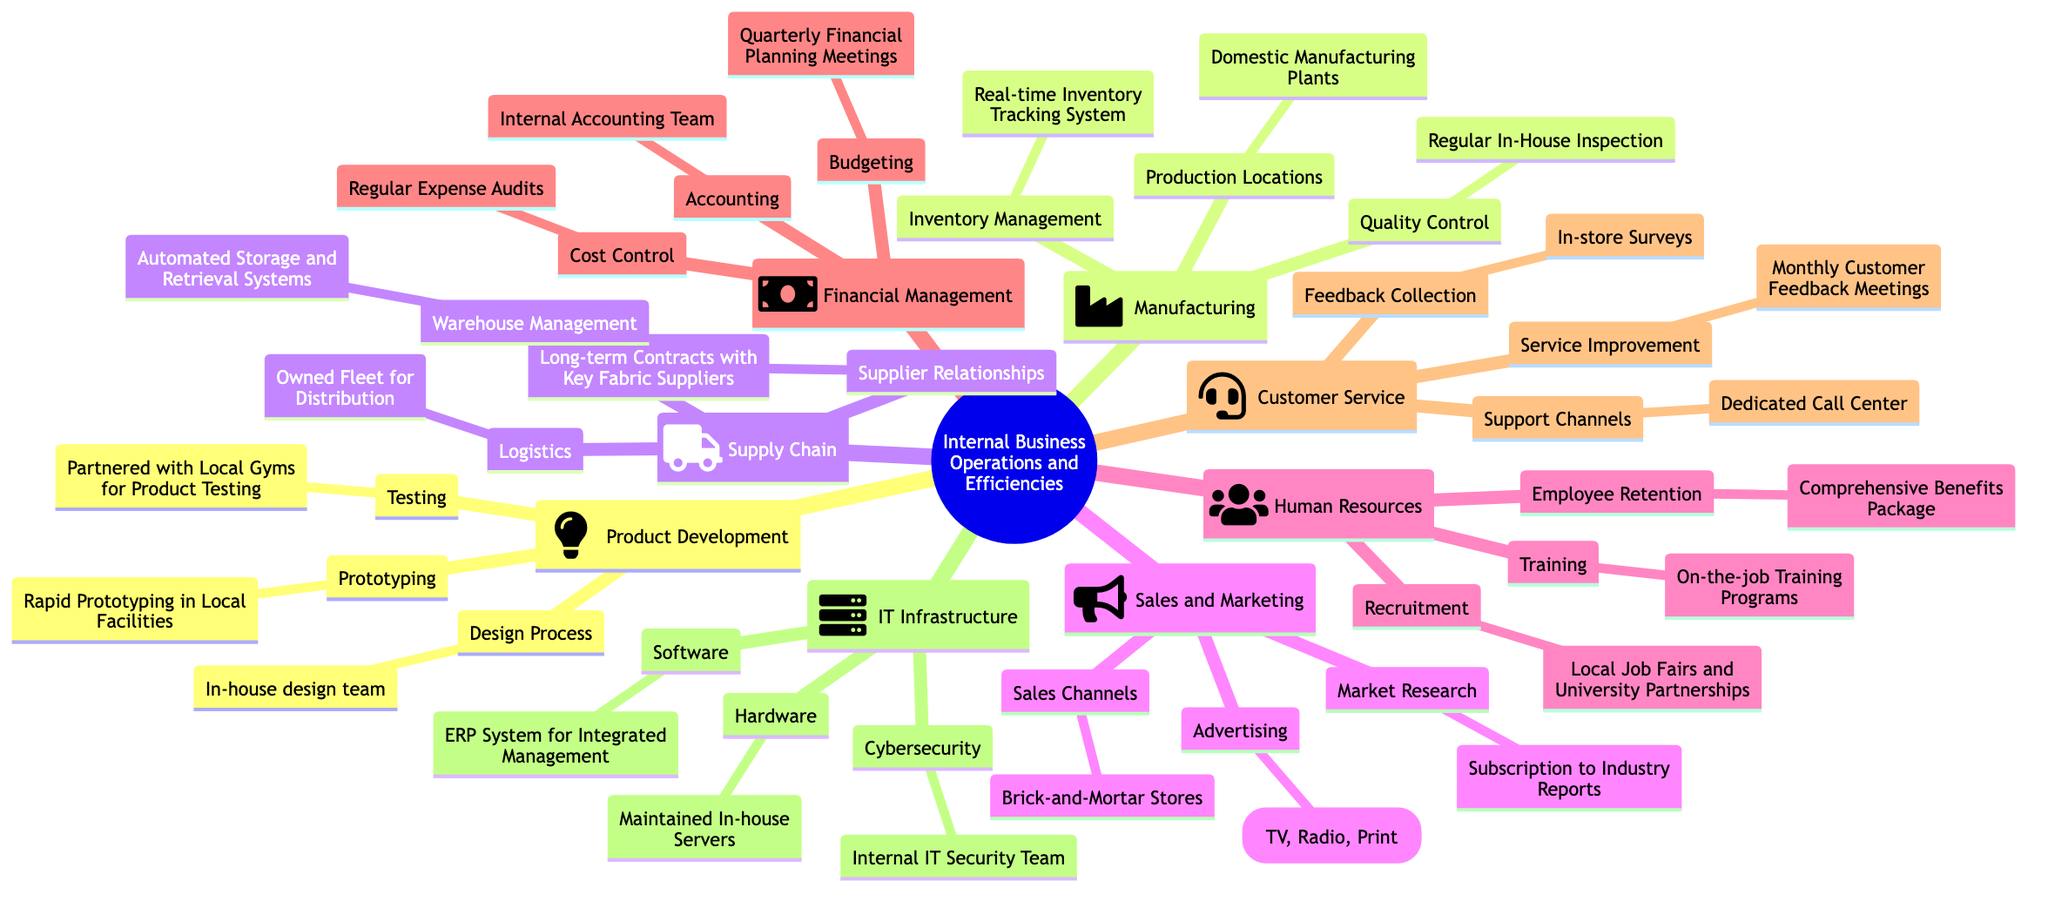What is the design process for product development? The design process for product development, as indicated in the diagram, is handled by an in-house design team. This can be found directly under the "Product Development" branch, specifically in the "Design Process" node.
Answer: In-house design team How many main categories are there in the internal business operations? By counting the main branches stemming from the central node "Internal Business Operations and Efficiencies," there are eight main categories: Product Development, Manufacturing, Supply Chain, Sales and Marketing, Human Resources, Financial Management, Customer Service, and IT Infrastructure.
Answer: Eight What type of vehicle does the logistics use in the supply chain? The logistics in the supply chain, as shown in the diagram, utilizes an owned fleet for distribution. This information is found under the "Logistics" node in the "Supply Chain" section.
Answer: Owned fleet Which channels are used for advertising in sales and marketing? The advertising strategies used in sales and marketing include traditional channels such as TV, Radio, and Print. This information is located in the "Advertising" node under the "Sales and Marketing" category.
Answer: Traditional Channels (TV, Radio, Print) How are customer feedbacks collected? Customer feedbacks are collected through in-store surveys, which is outlined within the "Feedback Collection" node under the "Customer Service" section.
Answer: In-store Surveys What ensures employee retention in human resources? Comprehensive benefits packages are what ensure employee retention in the human resources department, as indicated in the "Employee Retention" node under the "Human Resources" category.
Answer: Comprehensive Benefits Package How often are financial planning meetings held? Financial planning meetings are held quarterly, as stated in the "Budgeting" node within the "Financial Management" section of the diagram.
Answer: Quarterly What type of system is used for integrated management in IT infrastructure? An ERP system is utilized for integrated management in IT infrastructure. This information is located in the "Software" node under the "IT Infrastructure" category.
Answer: ERP System Which type of product testing is conducted? Product testing is conducted with the help of partnered local gyms for product testing. This information is specified in the "Testing" node under "Product Development."
Answer: Partnered with Local Gyms for Product Testing 